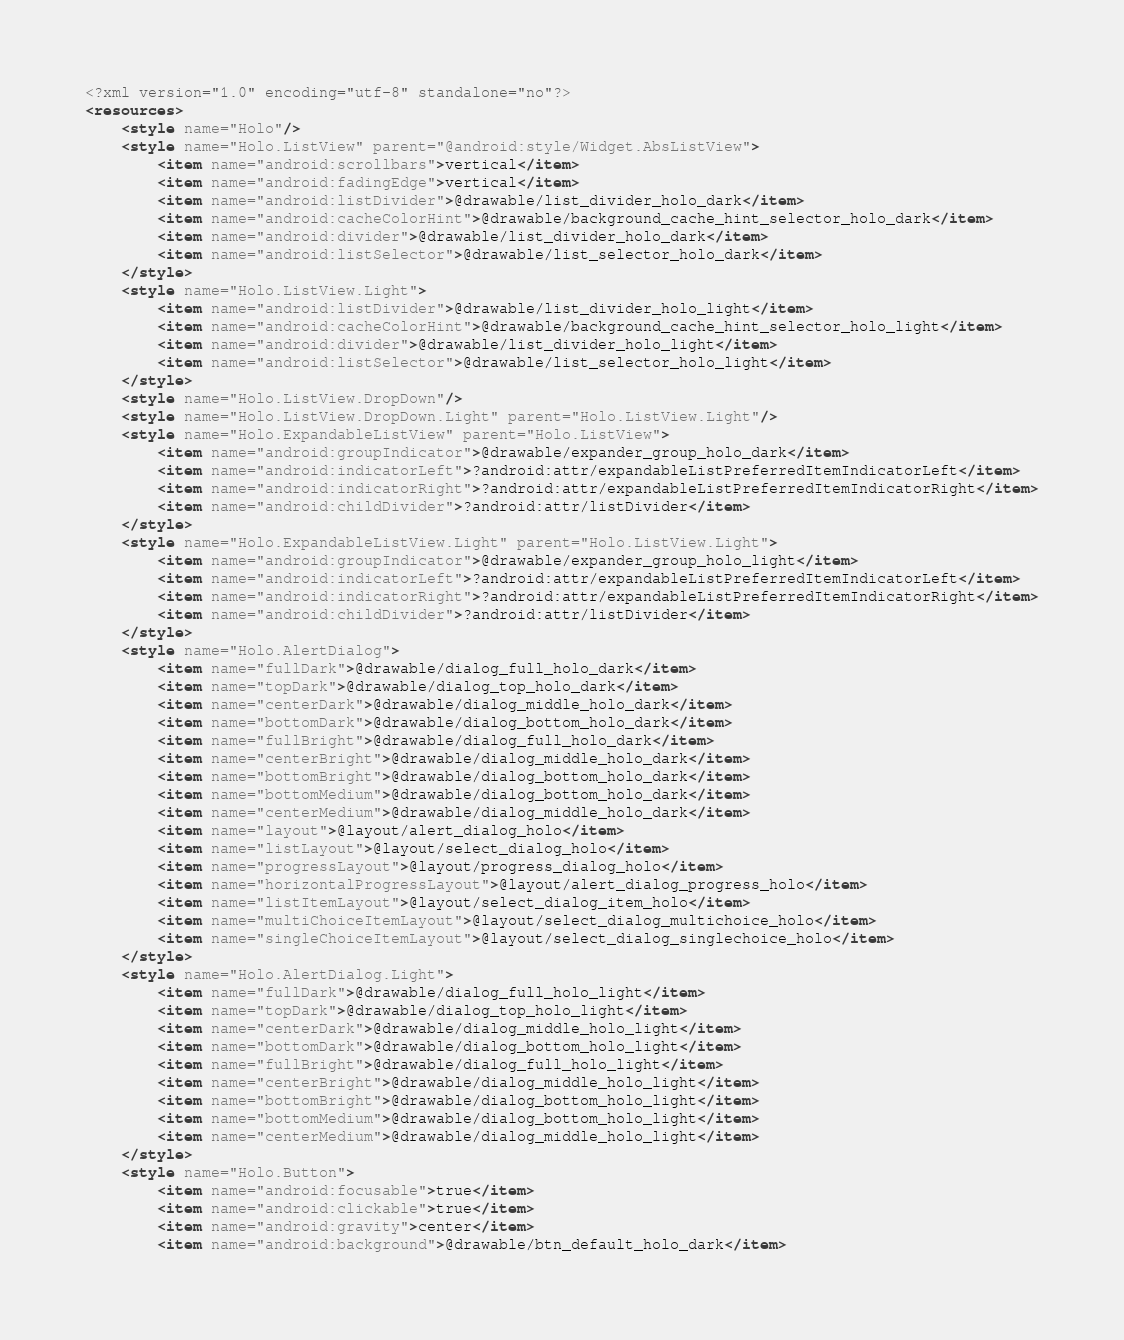<code> <loc_0><loc_0><loc_500><loc_500><_XML_><?xml version="1.0" encoding="utf-8" standalone="no"?>
<resources>
    <style name="Holo"/>
    <style name="Holo.ListView" parent="@android:style/Widget.AbsListView">
        <item name="android:scrollbars">vertical</item>
        <item name="android:fadingEdge">vertical</item>
        <item name="android:listDivider">@drawable/list_divider_holo_dark</item>
        <item name="android:cacheColorHint">@drawable/background_cache_hint_selector_holo_dark</item>
        <item name="android:divider">@drawable/list_divider_holo_dark</item>
        <item name="android:listSelector">@drawable/list_selector_holo_dark</item>
    </style>
    <style name="Holo.ListView.Light">
        <item name="android:listDivider">@drawable/list_divider_holo_light</item>
        <item name="android:cacheColorHint">@drawable/background_cache_hint_selector_holo_light</item>
        <item name="android:divider">@drawable/list_divider_holo_light</item>
        <item name="android:listSelector">@drawable/list_selector_holo_light</item>
    </style>
    <style name="Holo.ListView.DropDown"/>
    <style name="Holo.ListView.DropDown.Light" parent="Holo.ListView.Light"/>
    <style name="Holo.ExpandableListView" parent="Holo.ListView">
        <item name="android:groupIndicator">@drawable/expander_group_holo_dark</item>
        <item name="android:indicatorLeft">?android:attr/expandableListPreferredItemIndicatorLeft</item>
        <item name="android:indicatorRight">?android:attr/expandableListPreferredItemIndicatorRight</item>
        <item name="android:childDivider">?android:attr/listDivider</item>
    </style>
    <style name="Holo.ExpandableListView.Light" parent="Holo.ListView.Light">
        <item name="android:groupIndicator">@drawable/expander_group_holo_light</item>
        <item name="android:indicatorLeft">?android:attr/expandableListPreferredItemIndicatorLeft</item>
        <item name="android:indicatorRight">?android:attr/expandableListPreferredItemIndicatorRight</item>
        <item name="android:childDivider">?android:attr/listDivider</item>
    </style>
    <style name="Holo.AlertDialog">
        <item name="fullDark">@drawable/dialog_full_holo_dark</item>
        <item name="topDark">@drawable/dialog_top_holo_dark</item>
        <item name="centerDark">@drawable/dialog_middle_holo_dark</item>
        <item name="bottomDark">@drawable/dialog_bottom_holo_dark</item>
        <item name="fullBright">@drawable/dialog_full_holo_dark</item>
        <item name="centerBright">@drawable/dialog_middle_holo_dark</item>
        <item name="bottomBright">@drawable/dialog_bottom_holo_dark</item>
        <item name="bottomMedium">@drawable/dialog_bottom_holo_dark</item>
        <item name="centerMedium">@drawable/dialog_middle_holo_dark</item>
        <item name="layout">@layout/alert_dialog_holo</item>
        <item name="listLayout">@layout/select_dialog_holo</item>
        <item name="progressLayout">@layout/progress_dialog_holo</item>
        <item name="horizontalProgressLayout">@layout/alert_dialog_progress_holo</item>
        <item name="listItemLayout">@layout/select_dialog_item_holo</item>
        <item name="multiChoiceItemLayout">@layout/select_dialog_multichoice_holo</item>
        <item name="singleChoiceItemLayout">@layout/select_dialog_singlechoice_holo</item>
    </style>
    <style name="Holo.AlertDialog.Light">
        <item name="fullDark">@drawable/dialog_full_holo_light</item>
        <item name="topDark">@drawable/dialog_top_holo_light</item>
        <item name="centerDark">@drawable/dialog_middle_holo_light</item>
        <item name="bottomDark">@drawable/dialog_bottom_holo_light</item>
        <item name="fullBright">@drawable/dialog_full_holo_light</item>
        <item name="centerBright">@drawable/dialog_middle_holo_light</item>
        <item name="bottomBright">@drawable/dialog_bottom_holo_light</item>
        <item name="bottomMedium">@drawable/dialog_bottom_holo_light</item>
        <item name="centerMedium">@drawable/dialog_middle_holo_light</item>
    </style>
    <style name="Holo.Button">
        <item name="android:focusable">true</item>
        <item name="android:clickable">true</item>
        <item name="android:gravity">center</item>
        <item name="android:background">@drawable/btn_default_holo_dark</item></code> 